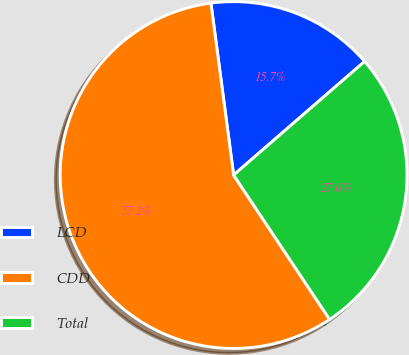<chart> <loc_0><loc_0><loc_500><loc_500><pie_chart><fcel>LCD<fcel>CDD<fcel>Total<nl><fcel>15.72%<fcel>57.25%<fcel>27.03%<nl></chart> 